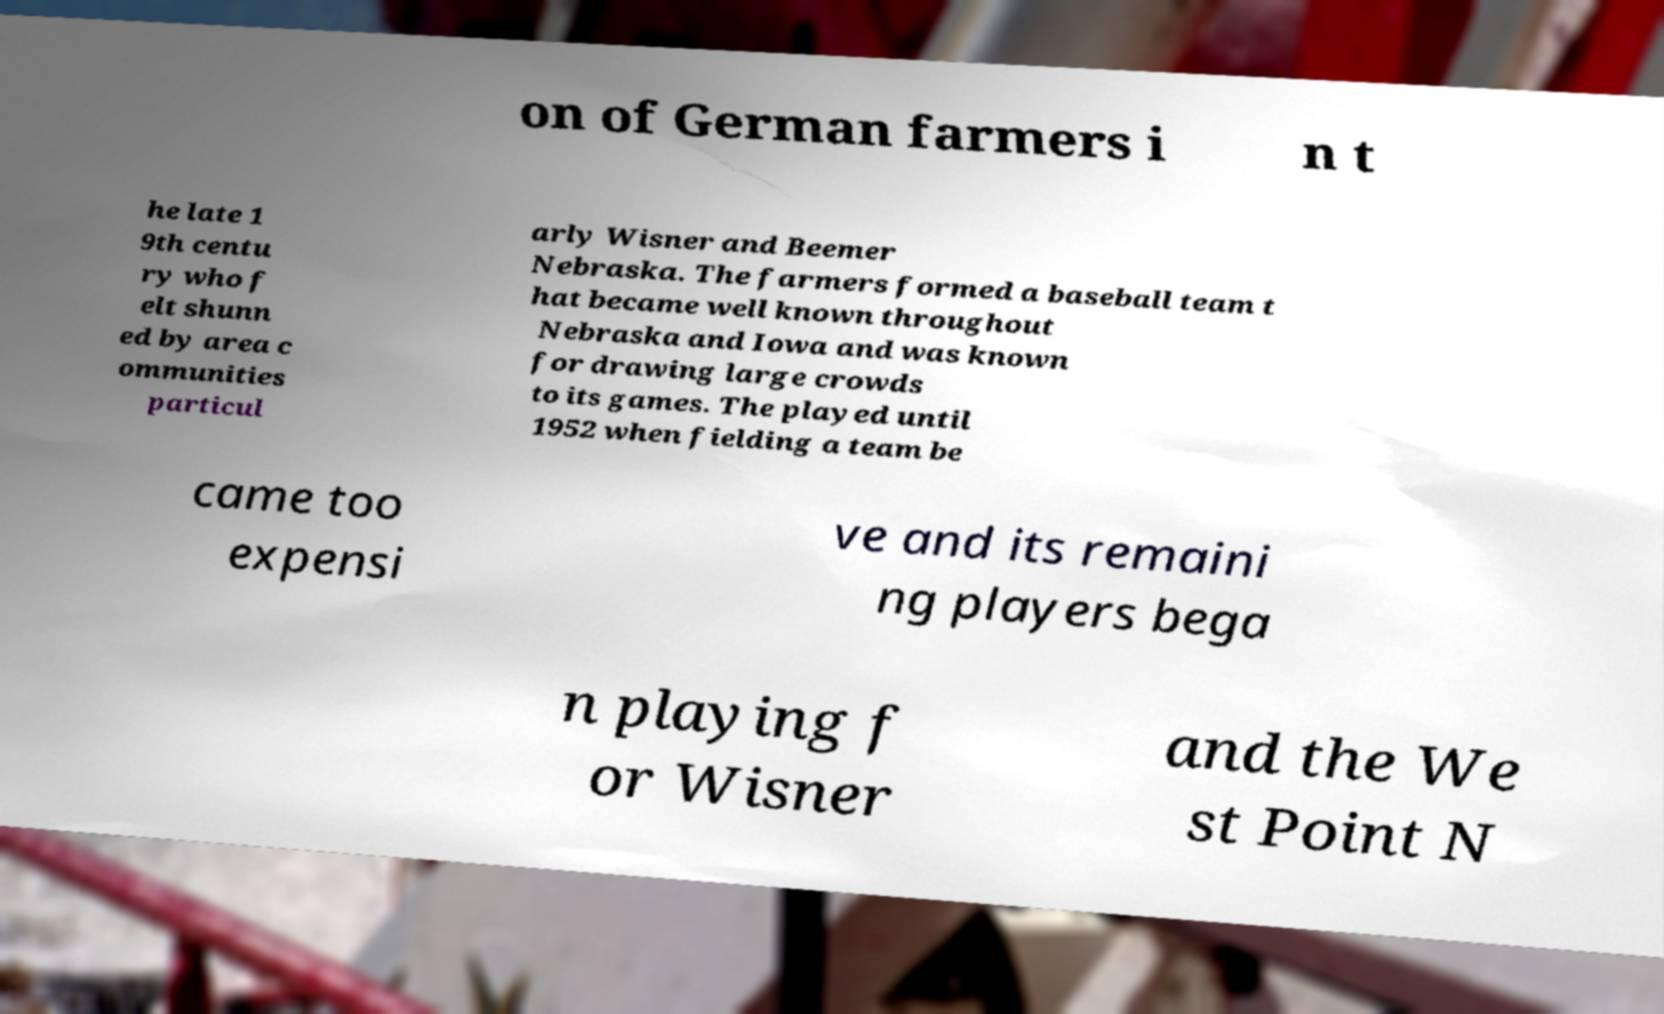I need the written content from this picture converted into text. Can you do that? on of German farmers i n t he late 1 9th centu ry who f elt shunn ed by area c ommunities particul arly Wisner and Beemer Nebraska. The farmers formed a baseball team t hat became well known throughout Nebraska and Iowa and was known for drawing large crowds to its games. The played until 1952 when fielding a team be came too expensi ve and its remaini ng players bega n playing f or Wisner and the We st Point N 